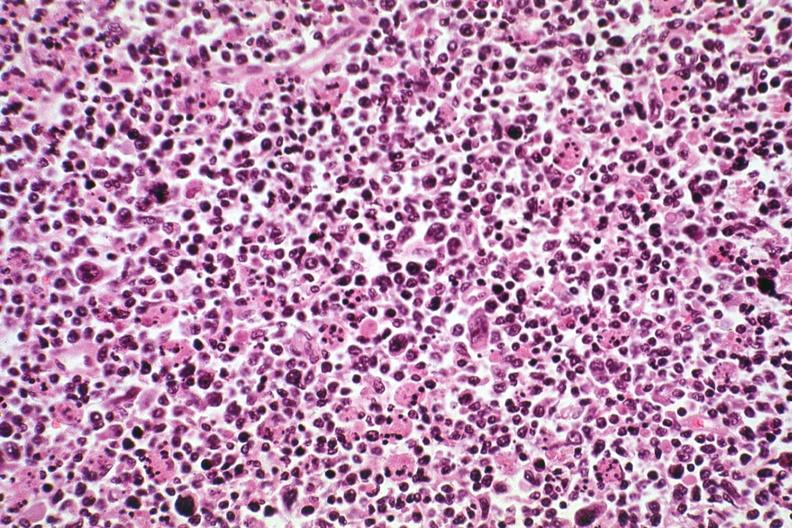s this typical thecoma with yellow foci present?
Answer the question using a single word or phrase. No 